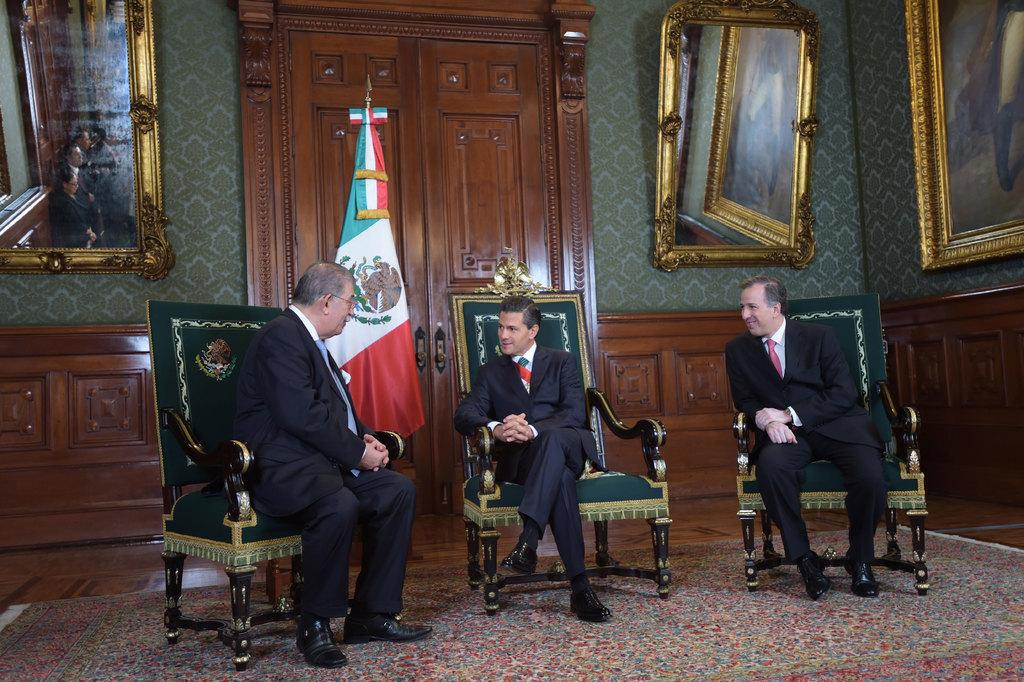How many people are in the image? There are three men in the image. What are the men doing in the image? The men are sitting on chairs and talking to each other. What can be seen in the background of the image? There is a door, a flag, and mirrors on the wall in the background of the image. What type of thunder can be heard in the image? There is no thunder present in the image; it is a still image with no sound. 